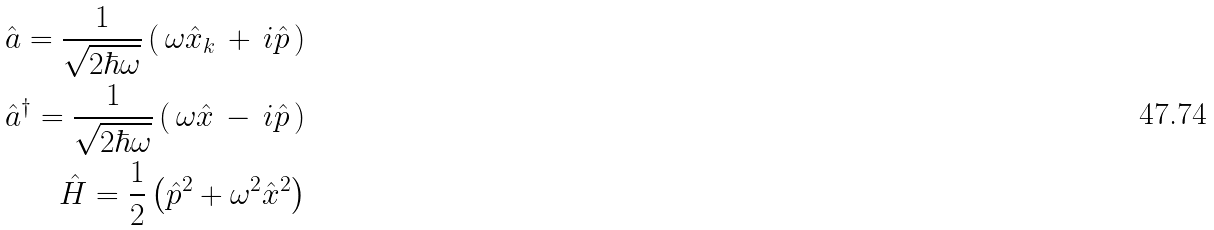Convert formula to latex. <formula><loc_0><loc_0><loc_500><loc_500>\hat { a } = \frac { 1 } { \sqrt { 2 \hbar { \omega } } } \left ( \, \omega \hat { x } _ { k } \, + \, i \hat { p } \, \right ) \\ \hat { a } ^ { \dag } = \frac { 1 } { \sqrt { 2 \hbar { \omega } } } \left ( \, \omega \hat { x } \, - \, i \hat { p } \, \right ) \\ \hat { H } = \frac { 1 } { 2 } \left ( \hat { p } ^ { 2 } + \omega ^ { 2 } \hat { x } ^ { 2 } \right )</formula> 